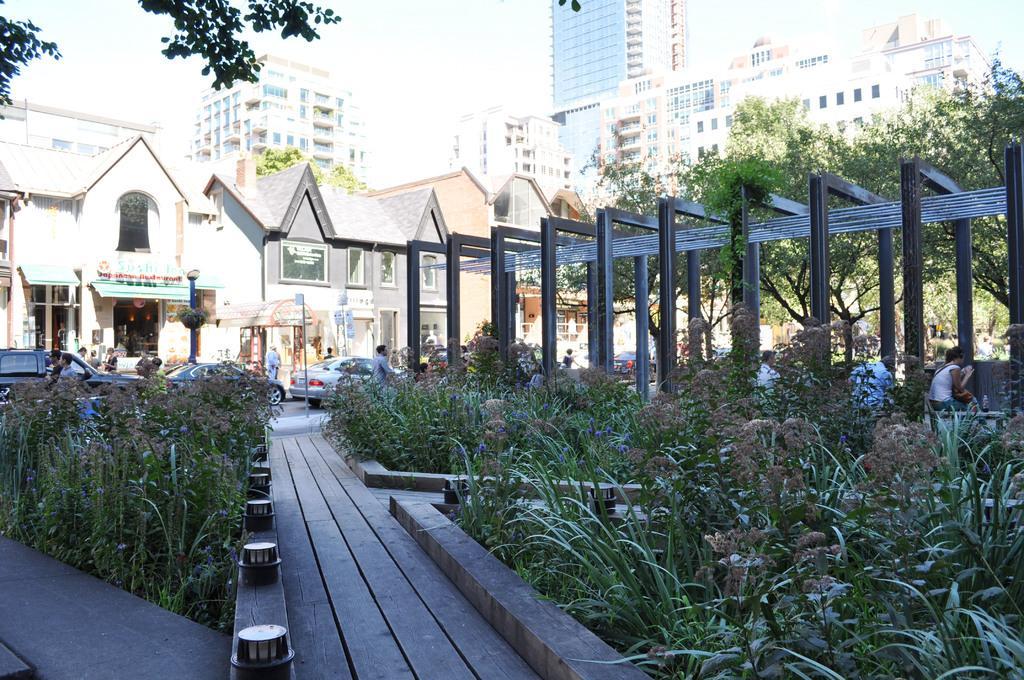Describe this image in one or two sentences. In the foreground of the picture there are plants, lights and path. In the center of the picture there are cars, people, trees, a construction and road. In the background there are buildings and tree. Sky is sunny. 